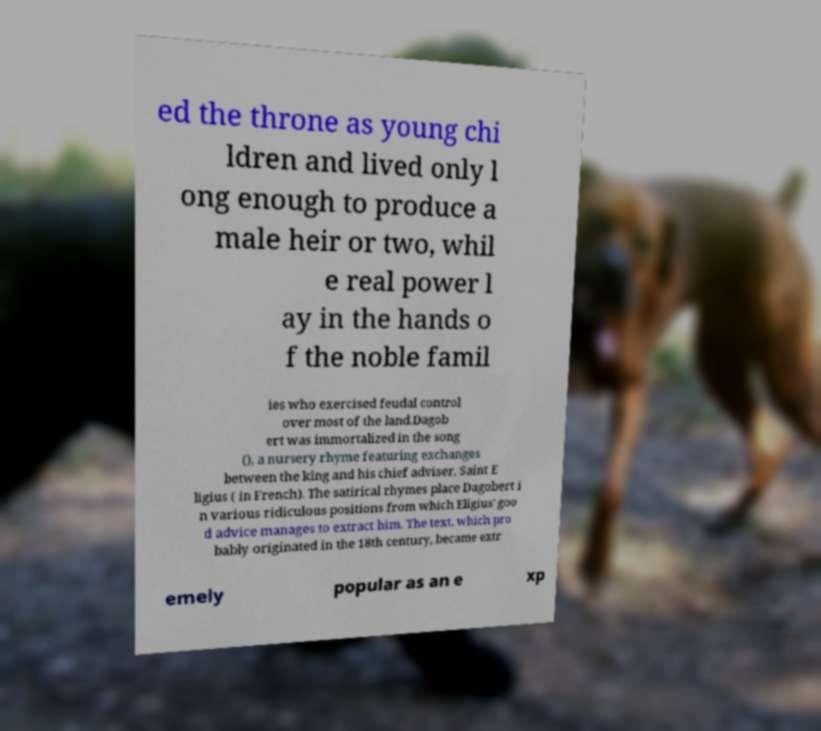Please identify and transcribe the text found in this image. ed the throne as young chi ldren and lived only l ong enough to produce a male heir or two, whil e real power l ay in the hands o f the noble famil ies who exercised feudal control over most of the land.Dagob ert was immortalized in the song (), a nursery rhyme featuring exchanges between the king and his chief adviser, Saint E ligius ( in French). The satirical rhymes place Dagobert i n various ridiculous positions from which Eligius' goo d advice manages to extract him. The text, which pro bably originated in the 18th century, became extr emely popular as an e xp 